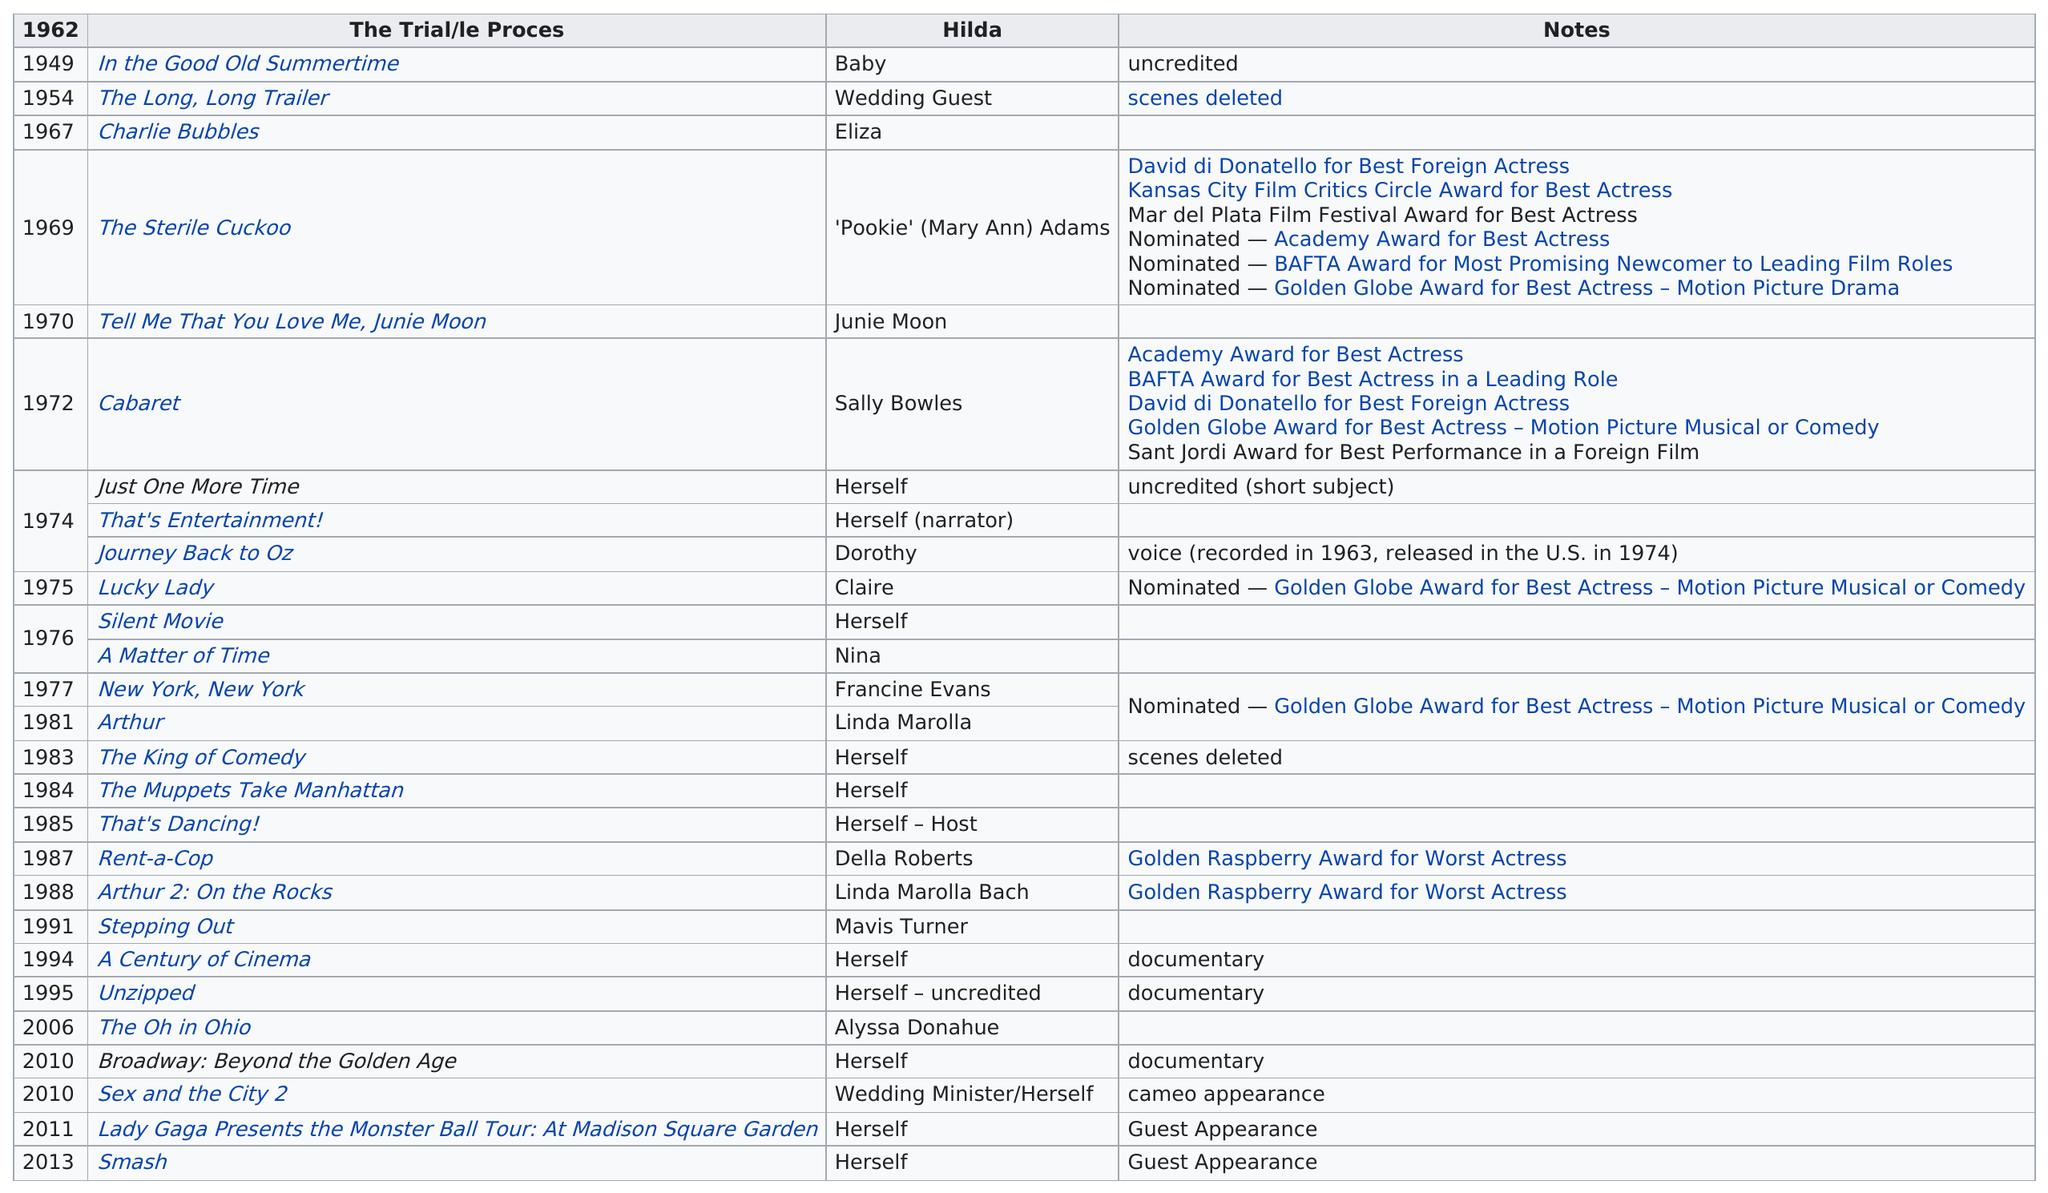Identify some key points in this picture. In how many films is the role listed as 'herself'? 10.." is a question asking for the number of times a particular role was listed as "herself" in a specified number of films. The actress received the Academy Award for Best Actress and the Golden Globe Award for Best Actress-Motion Picture Drama for the film "Cabaret. In 1974, Luchino Visconti was involved in three films. She appeared in 9 movies after the film "Rent-a-Cop. Minelli's first film was released in 1949. 